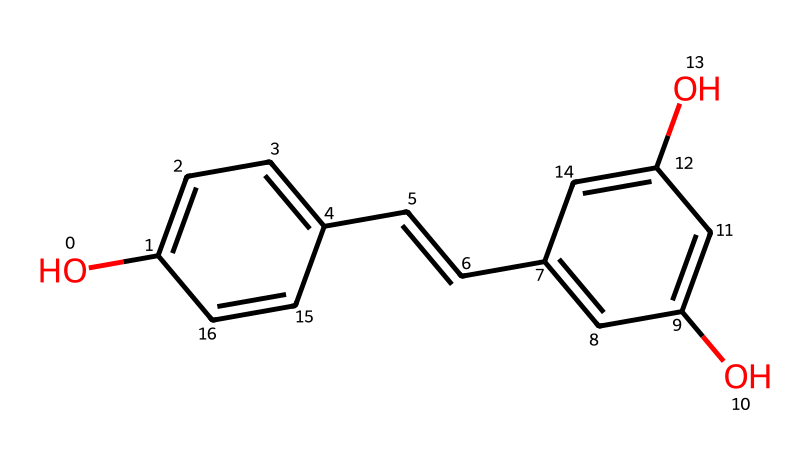What is the IUPAC name of this compound? The provided SMILES corresponds to the well-known compound resveratrol, which is identified by its systematic IUPAC name as 3,5,4'-trihydroxystilbene.
Answer: 3,5,4'-trihydroxystilbene How many hydroxyl groups are present in this compound? By examining the structure based on the SMILES, there are three -OH (hydroxyl) groups attached to the benzene rings, indicating the presence of three functional groups.
Answer: three What is the total number of rings in the structure of resveratrol? The chemical structure reveals two aromatic rings that are connected by a double bond, establishing the presence of two phenolic rings.
Answer: two What type of chemical structure does resveratrol possess? Analyzing the chemical, it has a stilbene structure, consisting of two aromatic rings connected by an ethylene bridge (the double bond).
Answer: stilbene Is resveratrol classified as a flavonoid? While resveratrol is a natural antioxidant, it does not belong to the flavonoid category; instead, it is classified as a polyphenol or stilbene, linking it to different biochemical properties.
Answer: no What two functional groups characterize resveratrol? The two key functional groups identified in resveratrol's structure are hydroxyl (-OH) groups and a double bond (C=C) that connects the phenolic rings.
Answer: hydroxyl and double bond 